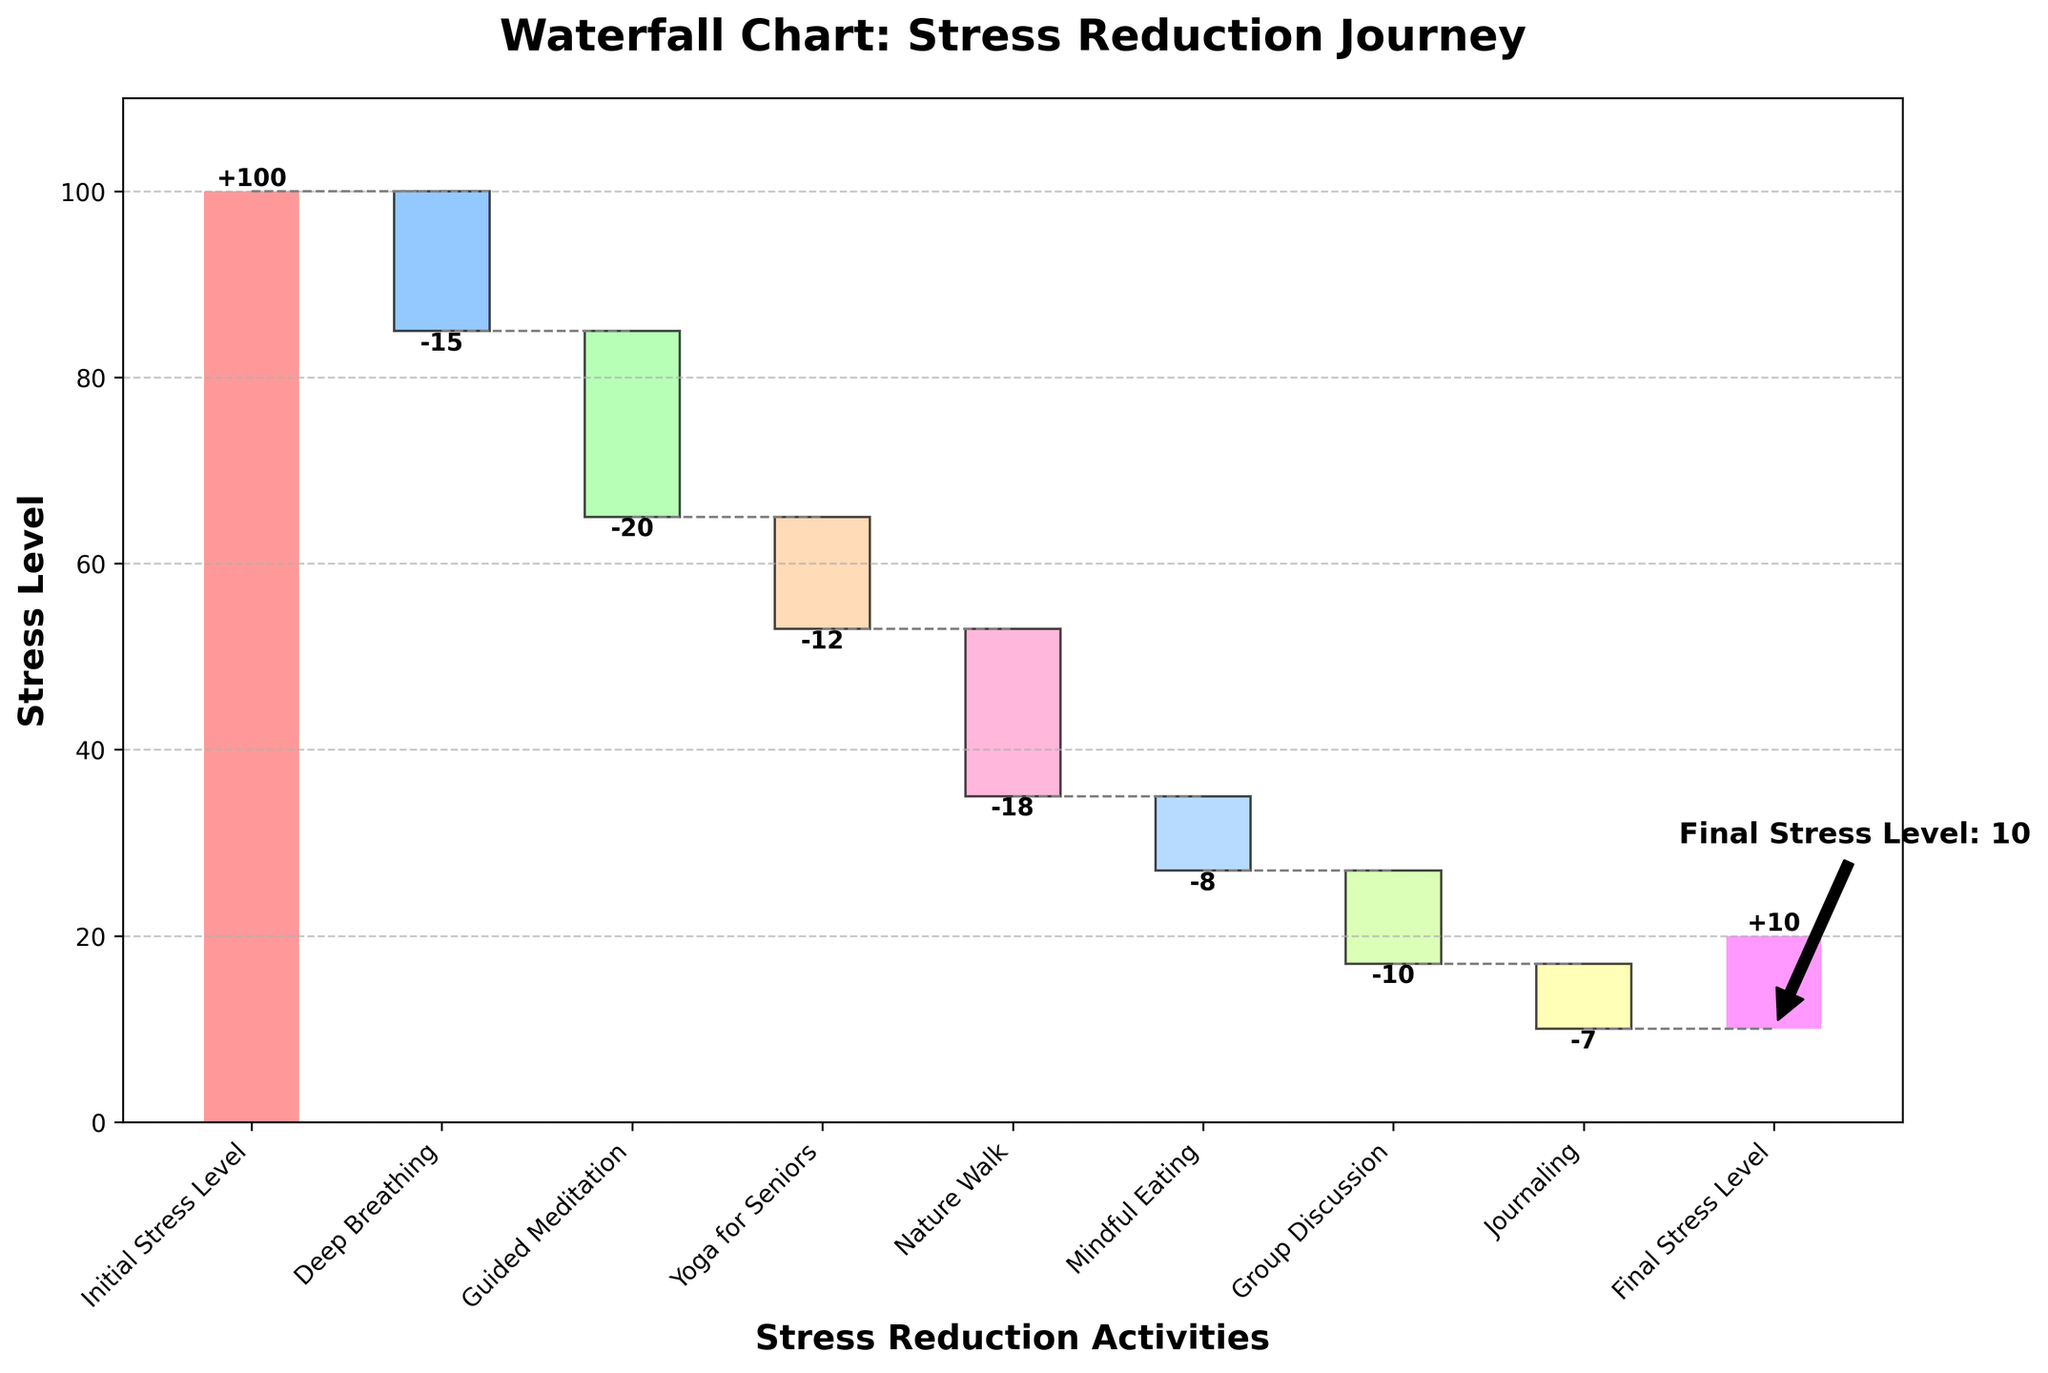What is the title of the chart? The title of the chart is written at the top and is typically one of the most noticeable text elements in the figure. In this case, it states the overall topic or purpose of the chart, which is "Waterfall Chart: Stress Reduction Journey."
Answer: Waterfall Chart: Stress Reduction Journey What is the initial stress level of the participants? The initial stress level is usually displayed on the far left of the chart. In this case, it reads 100, indicating the starting point before any activities were done.
Answer: 100 Which activity contributed the most to stress reduction? By comparing the lengths of the bars, guided meditation has the largest negative value, suggesting it contributed the most to stress reduction.
Answer: Guided Meditation What is the final stress level of the participants? The final stress level is represented at the far right of the chart. It has a positive value of 10, indicating the end result after all activities had been applied.
Answer: 10 How much did deep breathing contribute to stress reduction? The deep breathing activity is labeled on the x-axis, and the corresponding bar indicates it contributed negatively to stress levels by a value of -15, meaning it reduced stress.
Answer: -15 What is the net reduction in stress after the nature walk? The nature walk’s reduction value is -18 as indicated by the corresponding bar.
Answer: -18 Which activities resulted in a reduction of stress? Any activity with a negative value on the chart contributed to reducing stress. According to the chart, these are deep breathing, guided meditation, yoga for seniors, nature walk, mindful eating, group discussion, and journaling.
Answer: Deep Breathing, Guided Meditation, Yoga for Seniors, Nature Walk, Mindful Eating, Group Discussion, Journaling Compare the stress reduction from yoga for seniors and group discussion. Which has a greater impact? By comparing the lengths of the bars, yoga for seniors has a value of -12, and group discussion has a value of -10, indicating yoga for seniors has a slightly greater impact on reducing stress.
Answer: Yoga for Seniors Which activity contributed the least to stress reduction? By comparing the lengths of the bars representing negative values, journaling has the smallest magnitude at -7, indicating it contributed the least to stress reduction.
Answer: Journaling What is the total cumulative reduction in stress from all activities combined before reaching the final stress level? To find the total reduction, sum all the negative values: -15 (deep breathing) + -20 (guided meditation) + -12 (yoga for seniors) + -18 (nature walk) + -8 (mindful eating) + -10 (group discussion) + -7 (journaling). The sum is -90. So, the total cumulative reduction is 100 (initial) - 10 (final) = 90.
Answer: 90 